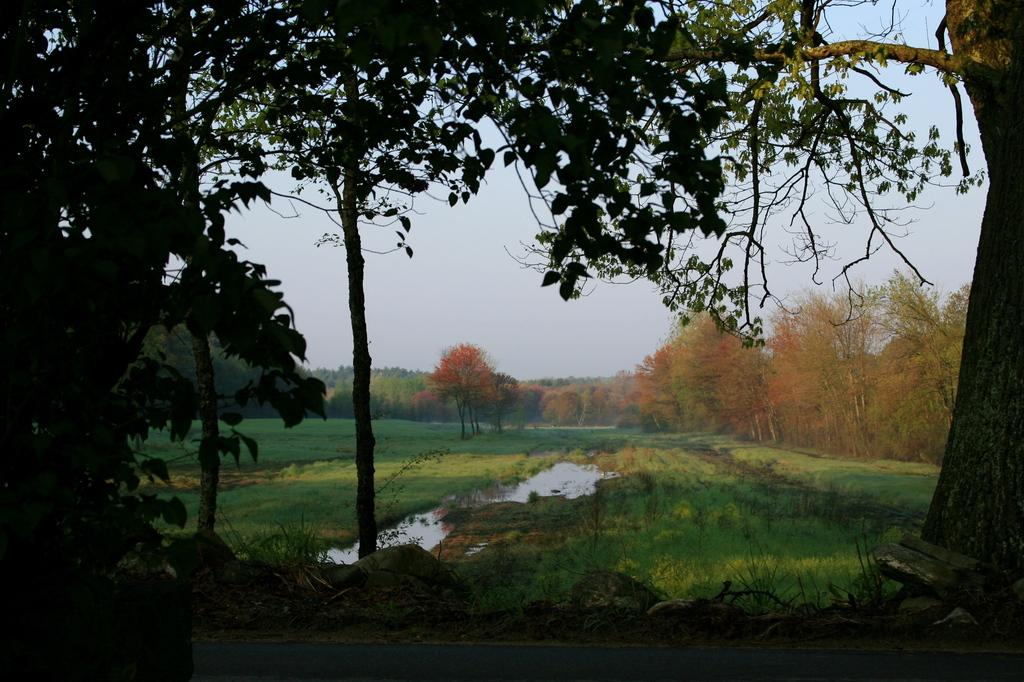What type of vegetation can be seen in the image? There are trees in the image. What type of plant life is growing in the image? There is a crop visible in the image. What natural element is present in the image? There is water visible in the image. What type of trees can be seen in the background of the image? There are maple trees in the background of the image. What is visible in the sky in the image? The sky is visible in the background of the image. How many sheep are visible in the image? There are no sheep present in the image. What type of wall can be seen surrounding the trees in the image? There is no wall present in the image; it features trees, a crop, water, maple trees, and the sky. 